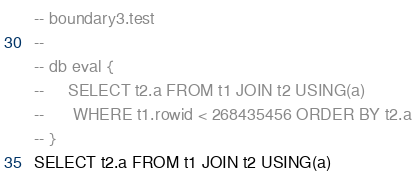<code> <loc_0><loc_0><loc_500><loc_500><_SQL_>-- boundary3.test
-- 
-- db eval {
--     SELECT t2.a FROM t1 JOIN t2 USING(a)
--      WHERE t1.rowid < 268435456 ORDER BY t2.a
-- }
SELECT t2.a FROM t1 JOIN t2 USING(a)</code> 